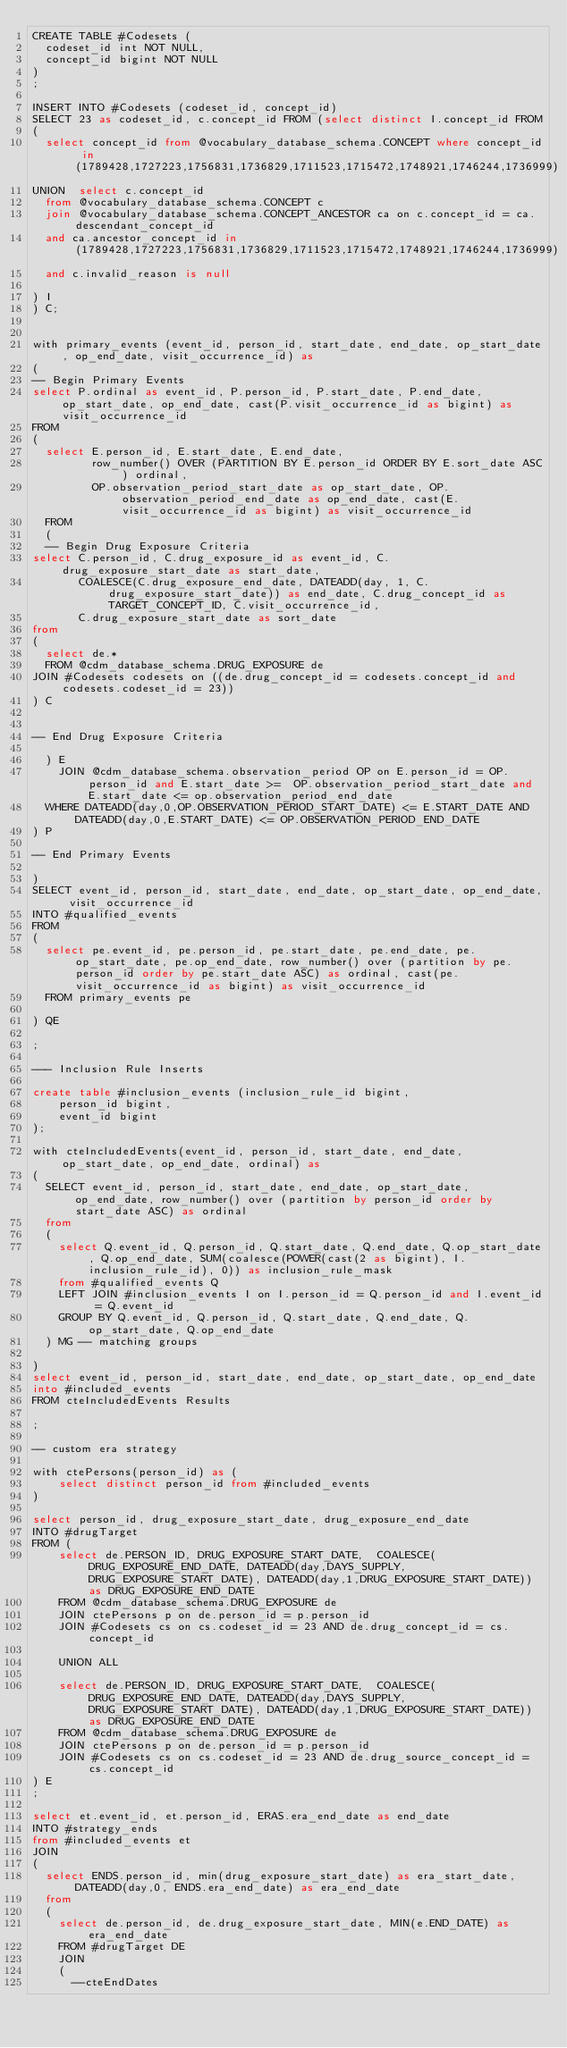Convert code to text. <code><loc_0><loc_0><loc_500><loc_500><_SQL_>CREATE TABLE #Codesets (
  codeset_id int NOT NULL,
  concept_id bigint NOT NULL
)
;

INSERT INTO #Codesets (codeset_id, concept_id)
SELECT 23 as codeset_id, c.concept_id FROM (select distinct I.concept_id FROM
( 
  select concept_id from @vocabulary_database_schema.CONCEPT where concept_id in (1789428,1727223,1756831,1736829,1711523,1715472,1748921,1746244,1736999)
UNION  select c.concept_id
  from @vocabulary_database_schema.CONCEPT c
  join @vocabulary_database_schema.CONCEPT_ANCESTOR ca on c.concept_id = ca.descendant_concept_id
  and ca.ancestor_concept_id in (1789428,1727223,1756831,1736829,1711523,1715472,1748921,1746244,1736999)
  and c.invalid_reason is null

) I
) C;


with primary_events (event_id, person_id, start_date, end_date, op_start_date, op_end_date, visit_occurrence_id) as
(
-- Begin Primary Events
select P.ordinal as event_id, P.person_id, P.start_date, P.end_date, op_start_date, op_end_date, cast(P.visit_occurrence_id as bigint) as visit_occurrence_id
FROM
(
  select E.person_id, E.start_date, E.end_date,
         row_number() OVER (PARTITION BY E.person_id ORDER BY E.sort_date ASC) ordinal,
         OP.observation_period_start_date as op_start_date, OP.observation_period_end_date as op_end_date, cast(E.visit_occurrence_id as bigint) as visit_occurrence_id
  FROM 
  (
  -- Begin Drug Exposure Criteria
select C.person_id, C.drug_exposure_id as event_id, C.drug_exposure_start_date as start_date,
       COALESCE(C.drug_exposure_end_date, DATEADD(day, 1, C.drug_exposure_start_date)) as end_date, C.drug_concept_id as TARGET_CONCEPT_ID, C.visit_occurrence_id,
       C.drug_exposure_start_date as sort_date
from 
(
  select de.* 
  FROM @cdm_database_schema.DRUG_EXPOSURE de
JOIN #Codesets codesets on ((de.drug_concept_id = codesets.concept_id and codesets.codeset_id = 23))
) C


-- End Drug Exposure Criteria

  ) E
	JOIN @cdm_database_schema.observation_period OP on E.person_id = OP.person_id and E.start_date >=  OP.observation_period_start_date and E.start_date <= op.observation_period_end_date
  WHERE DATEADD(day,0,OP.OBSERVATION_PERIOD_START_DATE) <= E.START_DATE AND DATEADD(day,0,E.START_DATE) <= OP.OBSERVATION_PERIOD_END_DATE
) P

-- End Primary Events

)
SELECT event_id, person_id, start_date, end_date, op_start_date, op_end_date, visit_occurrence_id
INTO #qualified_events
FROM 
(
  select pe.event_id, pe.person_id, pe.start_date, pe.end_date, pe.op_start_date, pe.op_end_date, row_number() over (partition by pe.person_id order by pe.start_date ASC) as ordinal, cast(pe.visit_occurrence_id as bigint) as visit_occurrence_id
  FROM primary_events pe
  
) QE

;

--- Inclusion Rule Inserts

create table #inclusion_events (inclusion_rule_id bigint,
	person_id bigint,
	event_id bigint
);

with cteIncludedEvents(event_id, person_id, start_date, end_date, op_start_date, op_end_date, ordinal) as
(
  SELECT event_id, person_id, start_date, end_date, op_start_date, op_end_date, row_number() over (partition by person_id order by start_date ASC) as ordinal
  from
  (
    select Q.event_id, Q.person_id, Q.start_date, Q.end_date, Q.op_start_date, Q.op_end_date, SUM(coalesce(POWER(cast(2 as bigint), I.inclusion_rule_id), 0)) as inclusion_rule_mask
    from #qualified_events Q
    LEFT JOIN #inclusion_events I on I.person_id = Q.person_id and I.event_id = Q.event_id
    GROUP BY Q.event_id, Q.person_id, Q.start_date, Q.end_date, Q.op_start_date, Q.op_end_date
  ) MG -- matching groups

)
select event_id, person_id, start_date, end_date, op_start_date, op_end_date
into #included_events
FROM cteIncludedEvents Results

;

-- custom era strategy

with ctePersons(person_id) as (
	select distinct person_id from #included_events
)

select person_id, drug_exposure_start_date, drug_exposure_end_date
INTO #drugTarget
FROM (
	select de.PERSON_ID, DRUG_EXPOSURE_START_DATE,  COALESCE(DRUG_EXPOSURE_END_DATE, DATEADD(day,DAYS_SUPPLY,DRUG_EXPOSURE_START_DATE), DATEADD(day,1,DRUG_EXPOSURE_START_DATE)) as DRUG_EXPOSURE_END_DATE 
	FROM @cdm_database_schema.DRUG_EXPOSURE de
	JOIN ctePersons p on de.person_id = p.person_id
	JOIN #Codesets cs on cs.codeset_id = 23 AND de.drug_concept_id = cs.concept_id

	UNION ALL

	select de.PERSON_ID, DRUG_EXPOSURE_START_DATE,  COALESCE(DRUG_EXPOSURE_END_DATE, DATEADD(day,DAYS_SUPPLY,DRUG_EXPOSURE_START_DATE), DATEADD(day,1,DRUG_EXPOSURE_START_DATE)) as DRUG_EXPOSURE_END_DATE 
	FROM @cdm_database_schema.DRUG_EXPOSURE de
	JOIN ctePersons p on de.person_id = p.person_id
	JOIN #Codesets cs on cs.codeset_id = 23 AND de.drug_source_concept_id = cs.concept_id
) E
;

select et.event_id, et.person_id, ERAS.era_end_date as end_date
INTO #strategy_ends
from #included_events et
JOIN 
(
  select ENDS.person_id, min(drug_exposure_start_date) as era_start_date, DATEADD(day,0, ENDS.era_end_date) as era_end_date
  from
  (
    select de.person_id, de.drug_exposure_start_date, MIN(e.END_DATE) as era_end_date
    FROM #drugTarget DE
    JOIN 
    (
      --cteEndDates</code> 